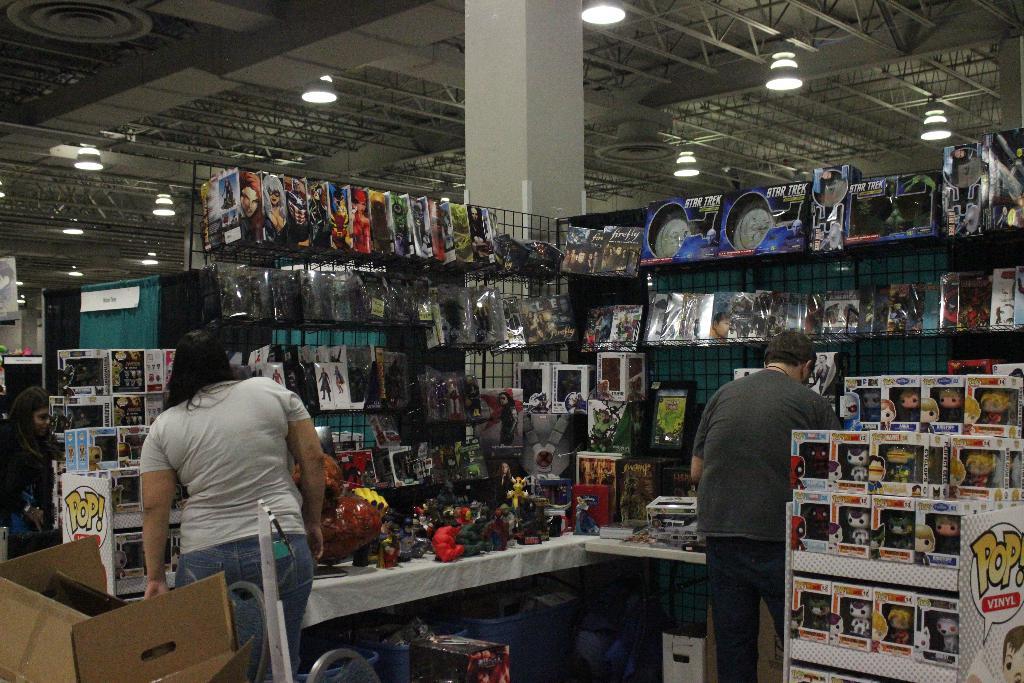What type of toys are these in the white boxes?
Offer a very short reply. Pop vinyl. 